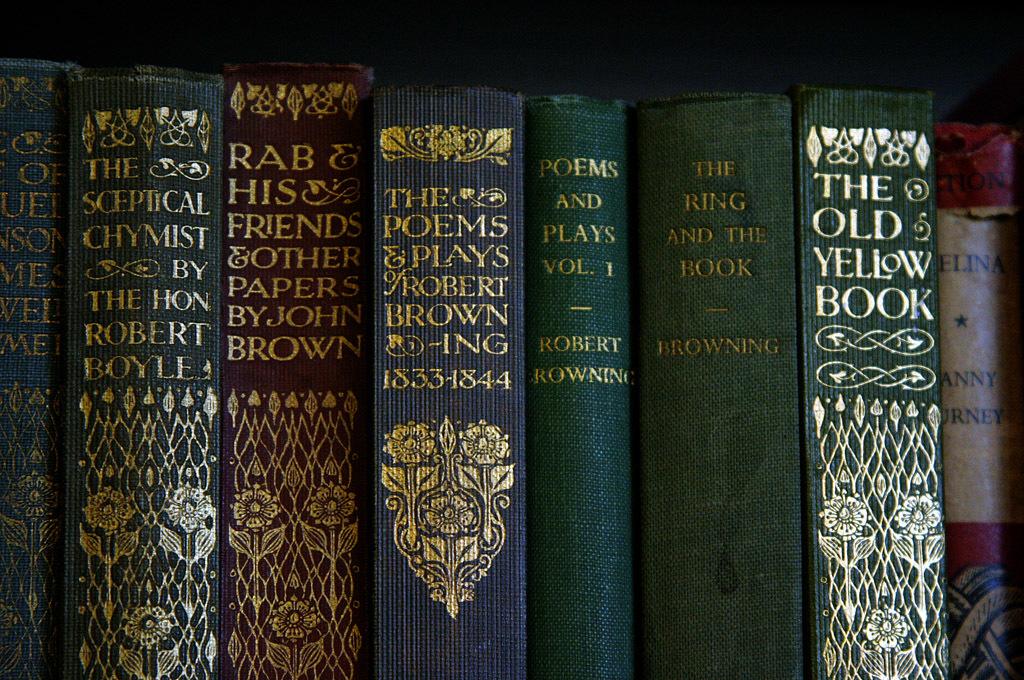Who wrote the ring and the book?
Provide a short and direct response. Browning. What years are on the spine of the blue middle book?
Make the answer very short. 1833-1844. 